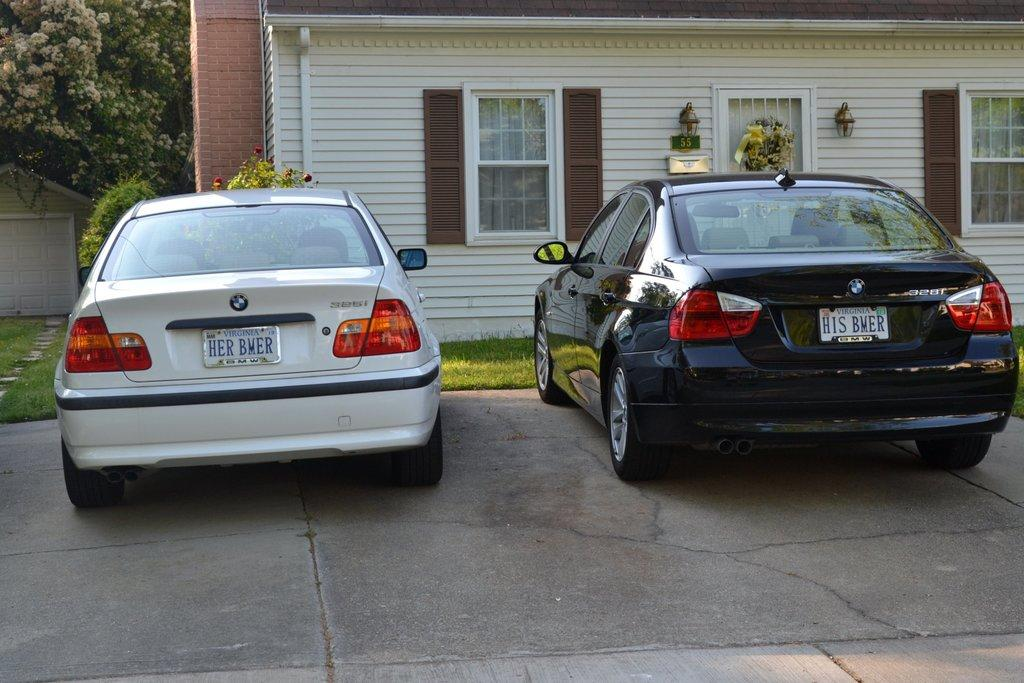Provide a one-sentence caption for the provided image. Two cars parked in front of a white house with vanity plates reading "Her BMER" and "His BMER.". 